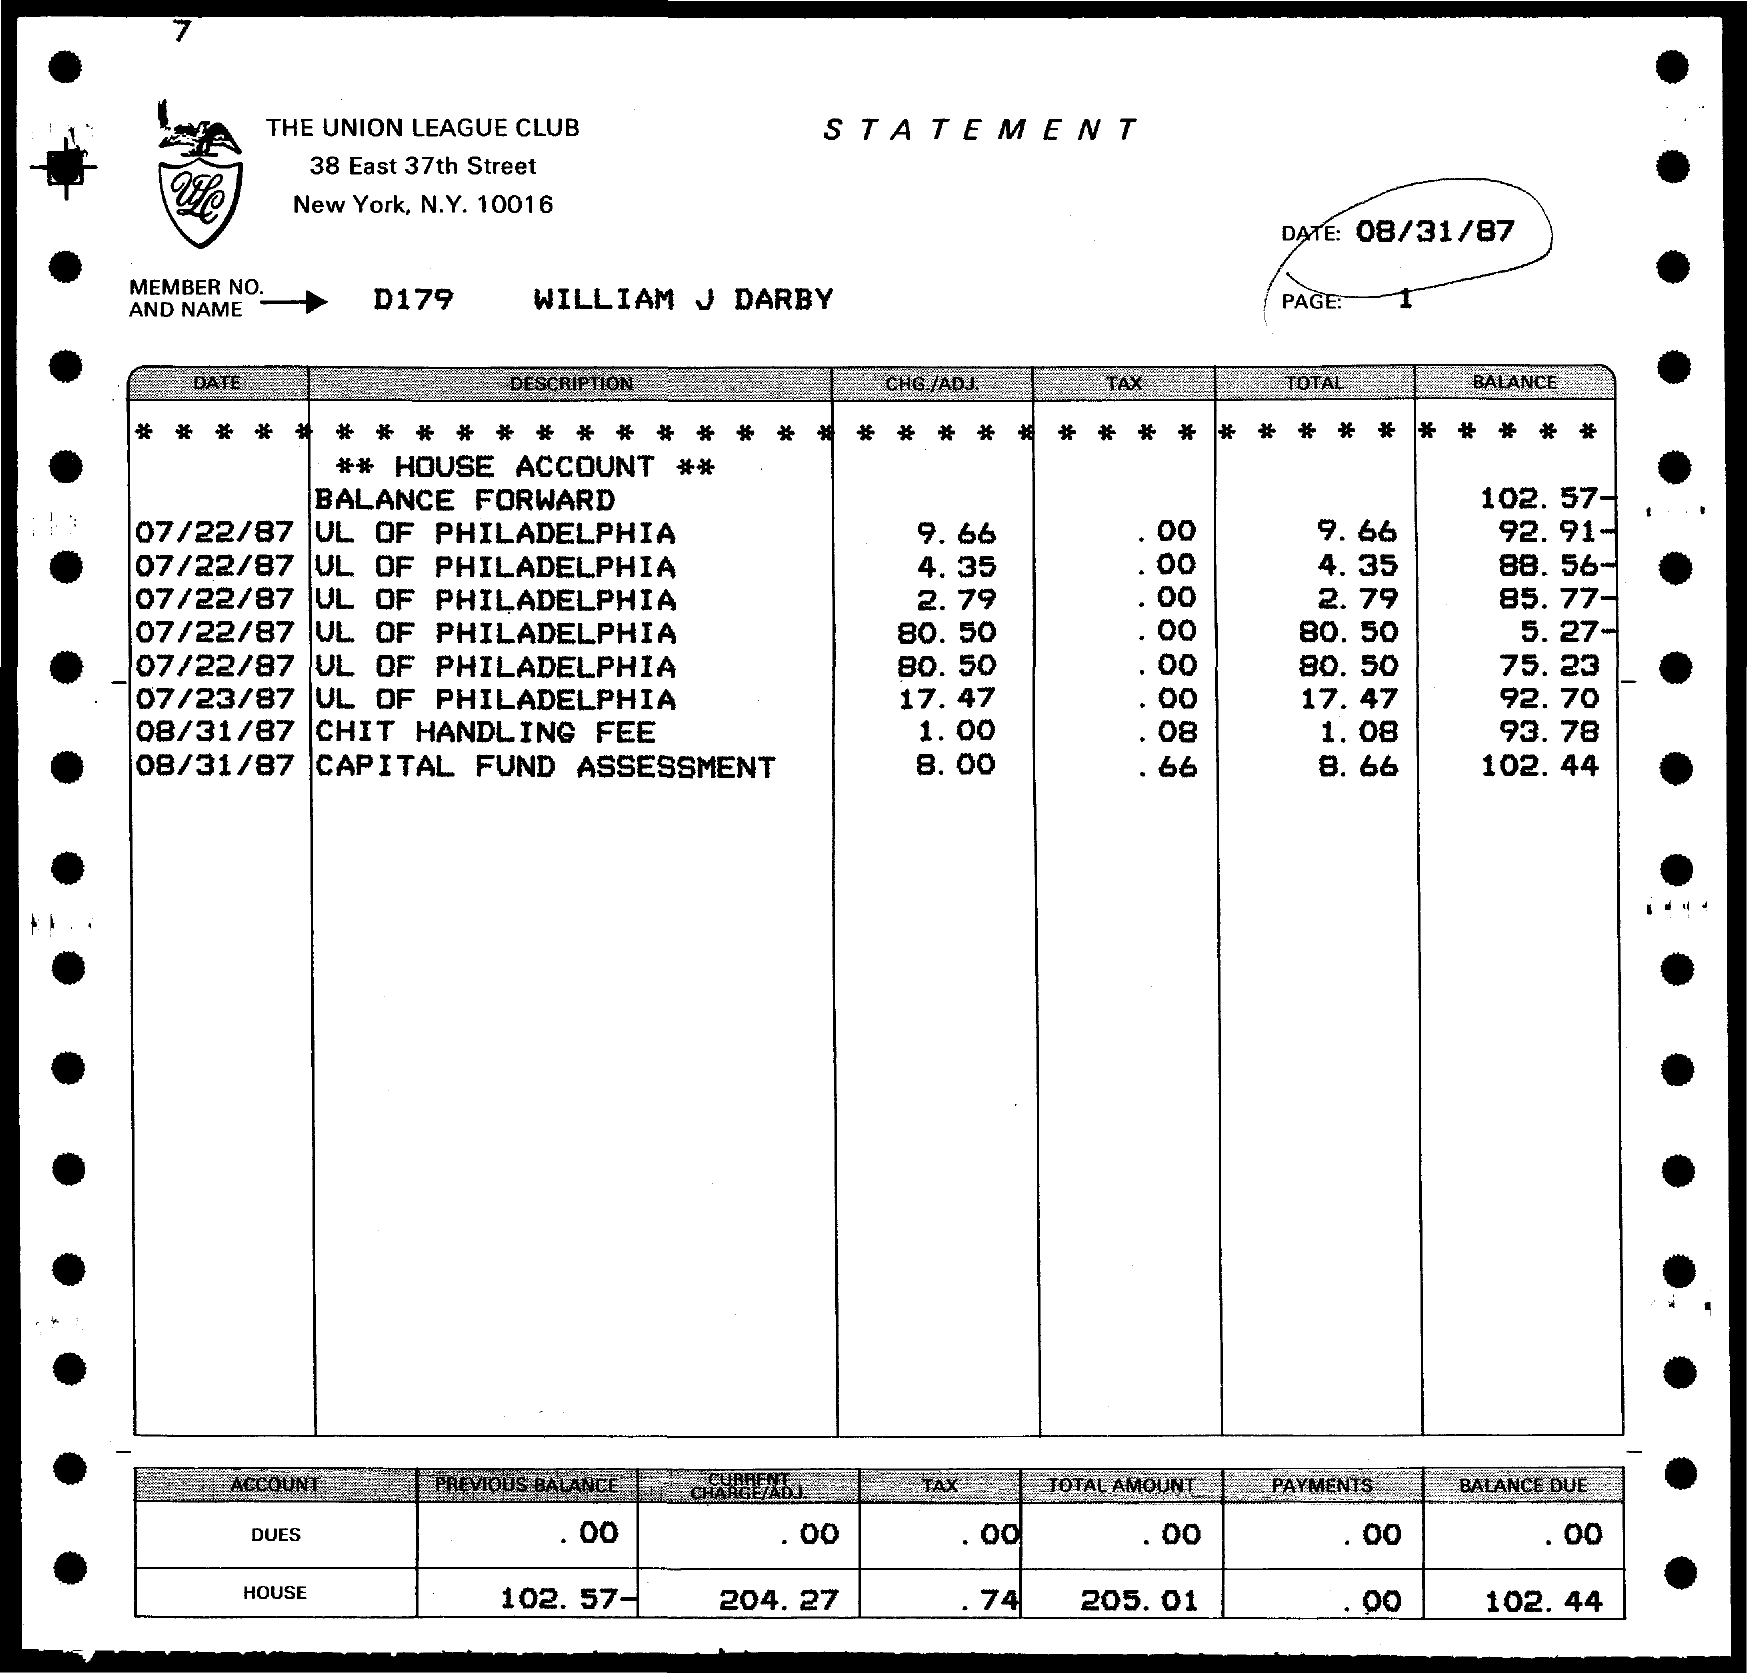Outline some significant characteristics in this image. The date mentioned in the given page is August 31, 1987. The total amount in the house account mentioned on the given page is 205.01. The amount of balance due in the house account, as mentioned on the given page, is 102.44... The given page mentions a previous balance of 102.57- for the house account. The Union League Club is the name of the club mentioned in the given page. 